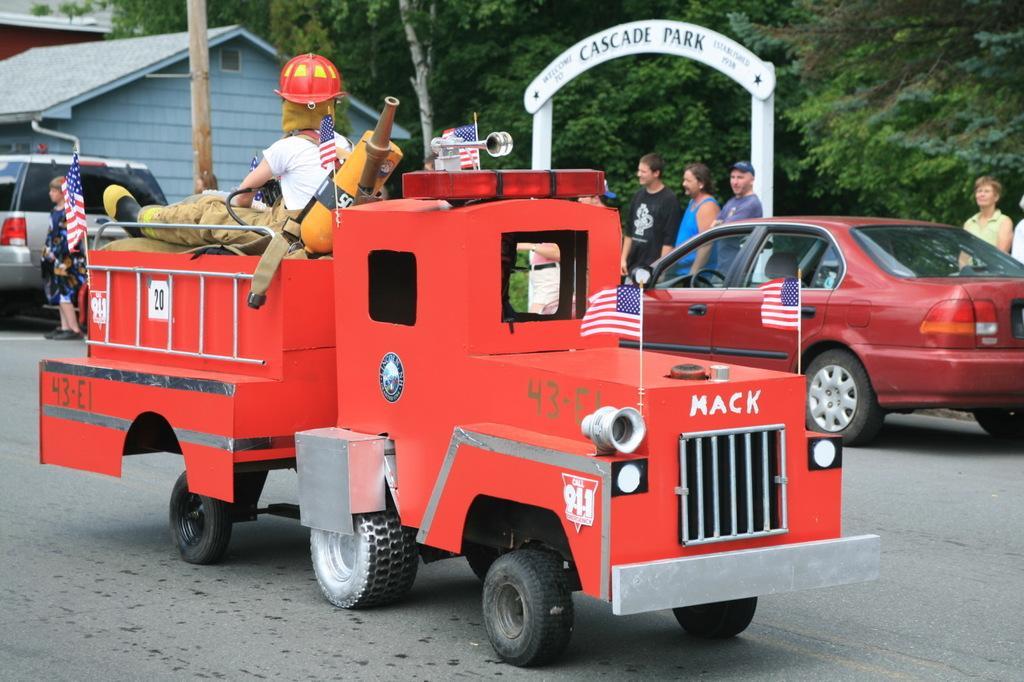Could you give a brief overview of what you see in this image? In this picture I can observe red color vehicles on the road. In the background there are some people and I can observe some trees. 